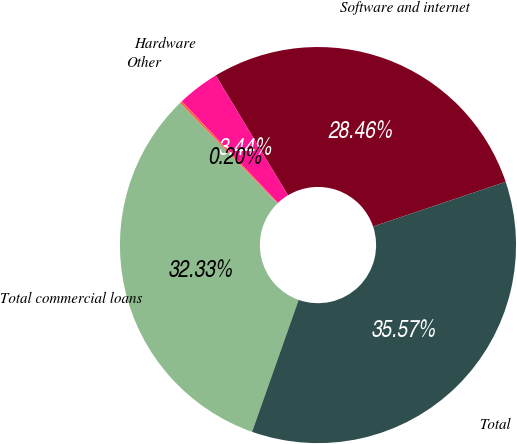<chart> <loc_0><loc_0><loc_500><loc_500><pie_chart><fcel>Software and internet<fcel>Hardware<fcel>Other<fcel>Total commercial loans<fcel>Total<nl><fcel>28.46%<fcel>3.44%<fcel>0.2%<fcel>32.33%<fcel>35.57%<nl></chart> 